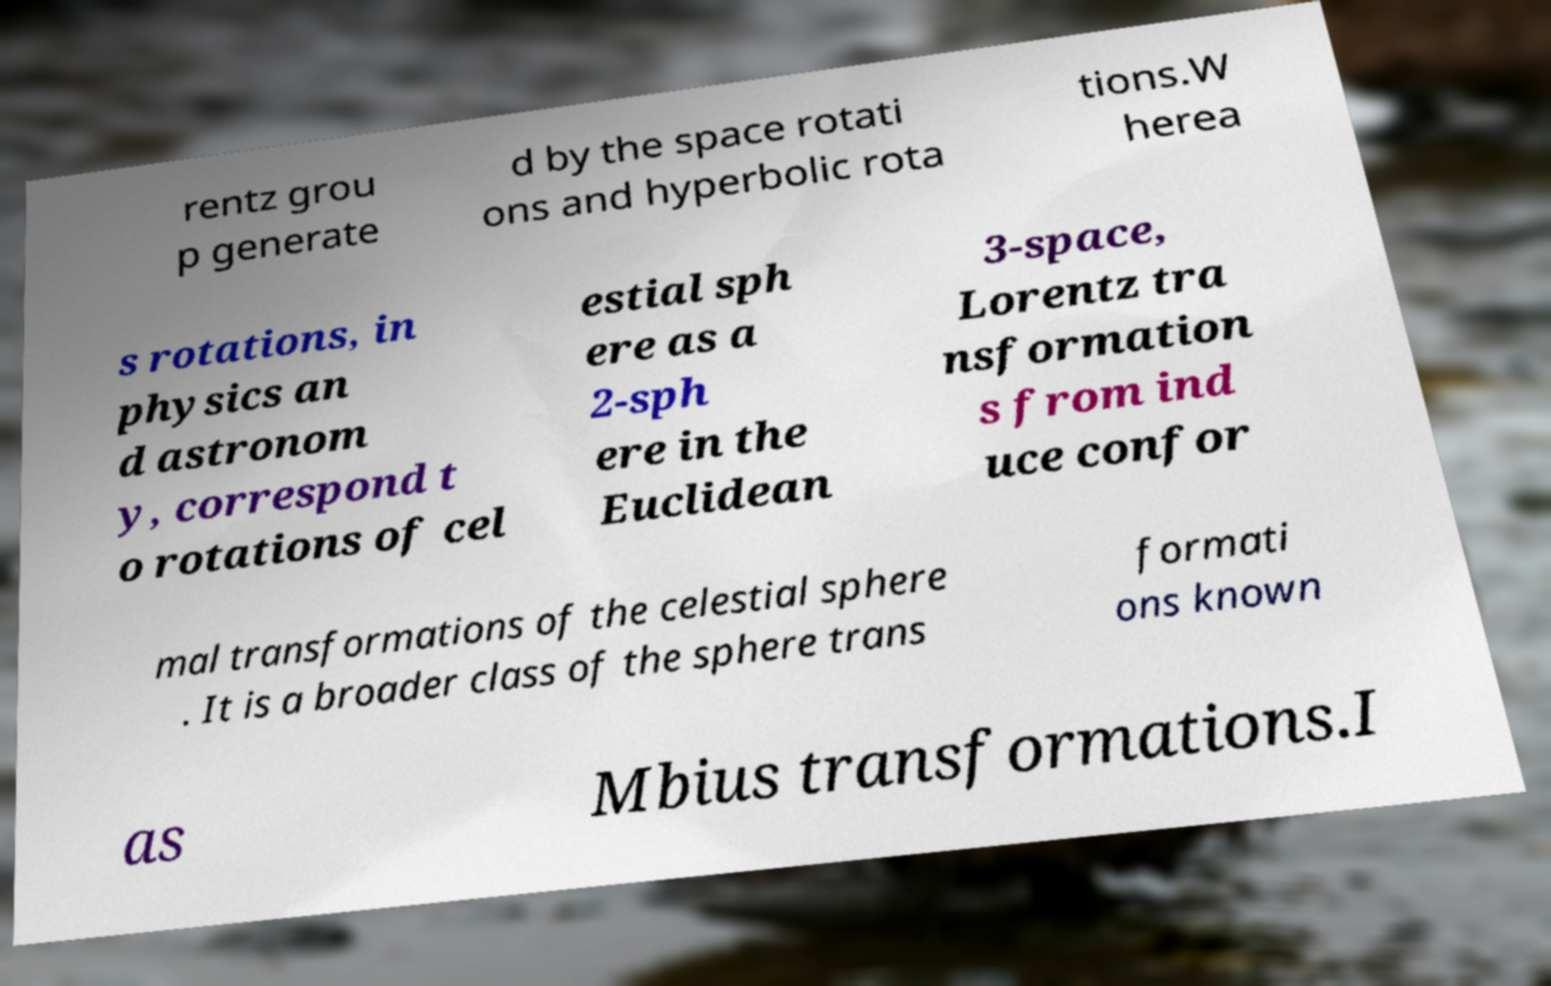Can you read and provide the text displayed in the image?This photo seems to have some interesting text. Can you extract and type it out for me? rentz grou p generate d by the space rotati ons and hyperbolic rota tions.W herea s rotations, in physics an d astronom y, correspond t o rotations of cel estial sph ere as a 2-sph ere in the Euclidean 3-space, Lorentz tra nsformation s from ind uce confor mal transformations of the celestial sphere . It is a broader class of the sphere trans formati ons known as Mbius transformations.I 